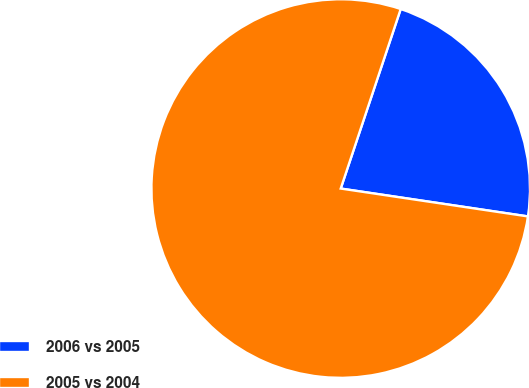Convert chart. <chart><loc_0><loc_0><loc_500><loc_500><pie_chart><fcel>2006 vs 2005<fcel>2005 vs 2004<nl><fcel>22.22%<fcel>77.78%<nl></chart> 